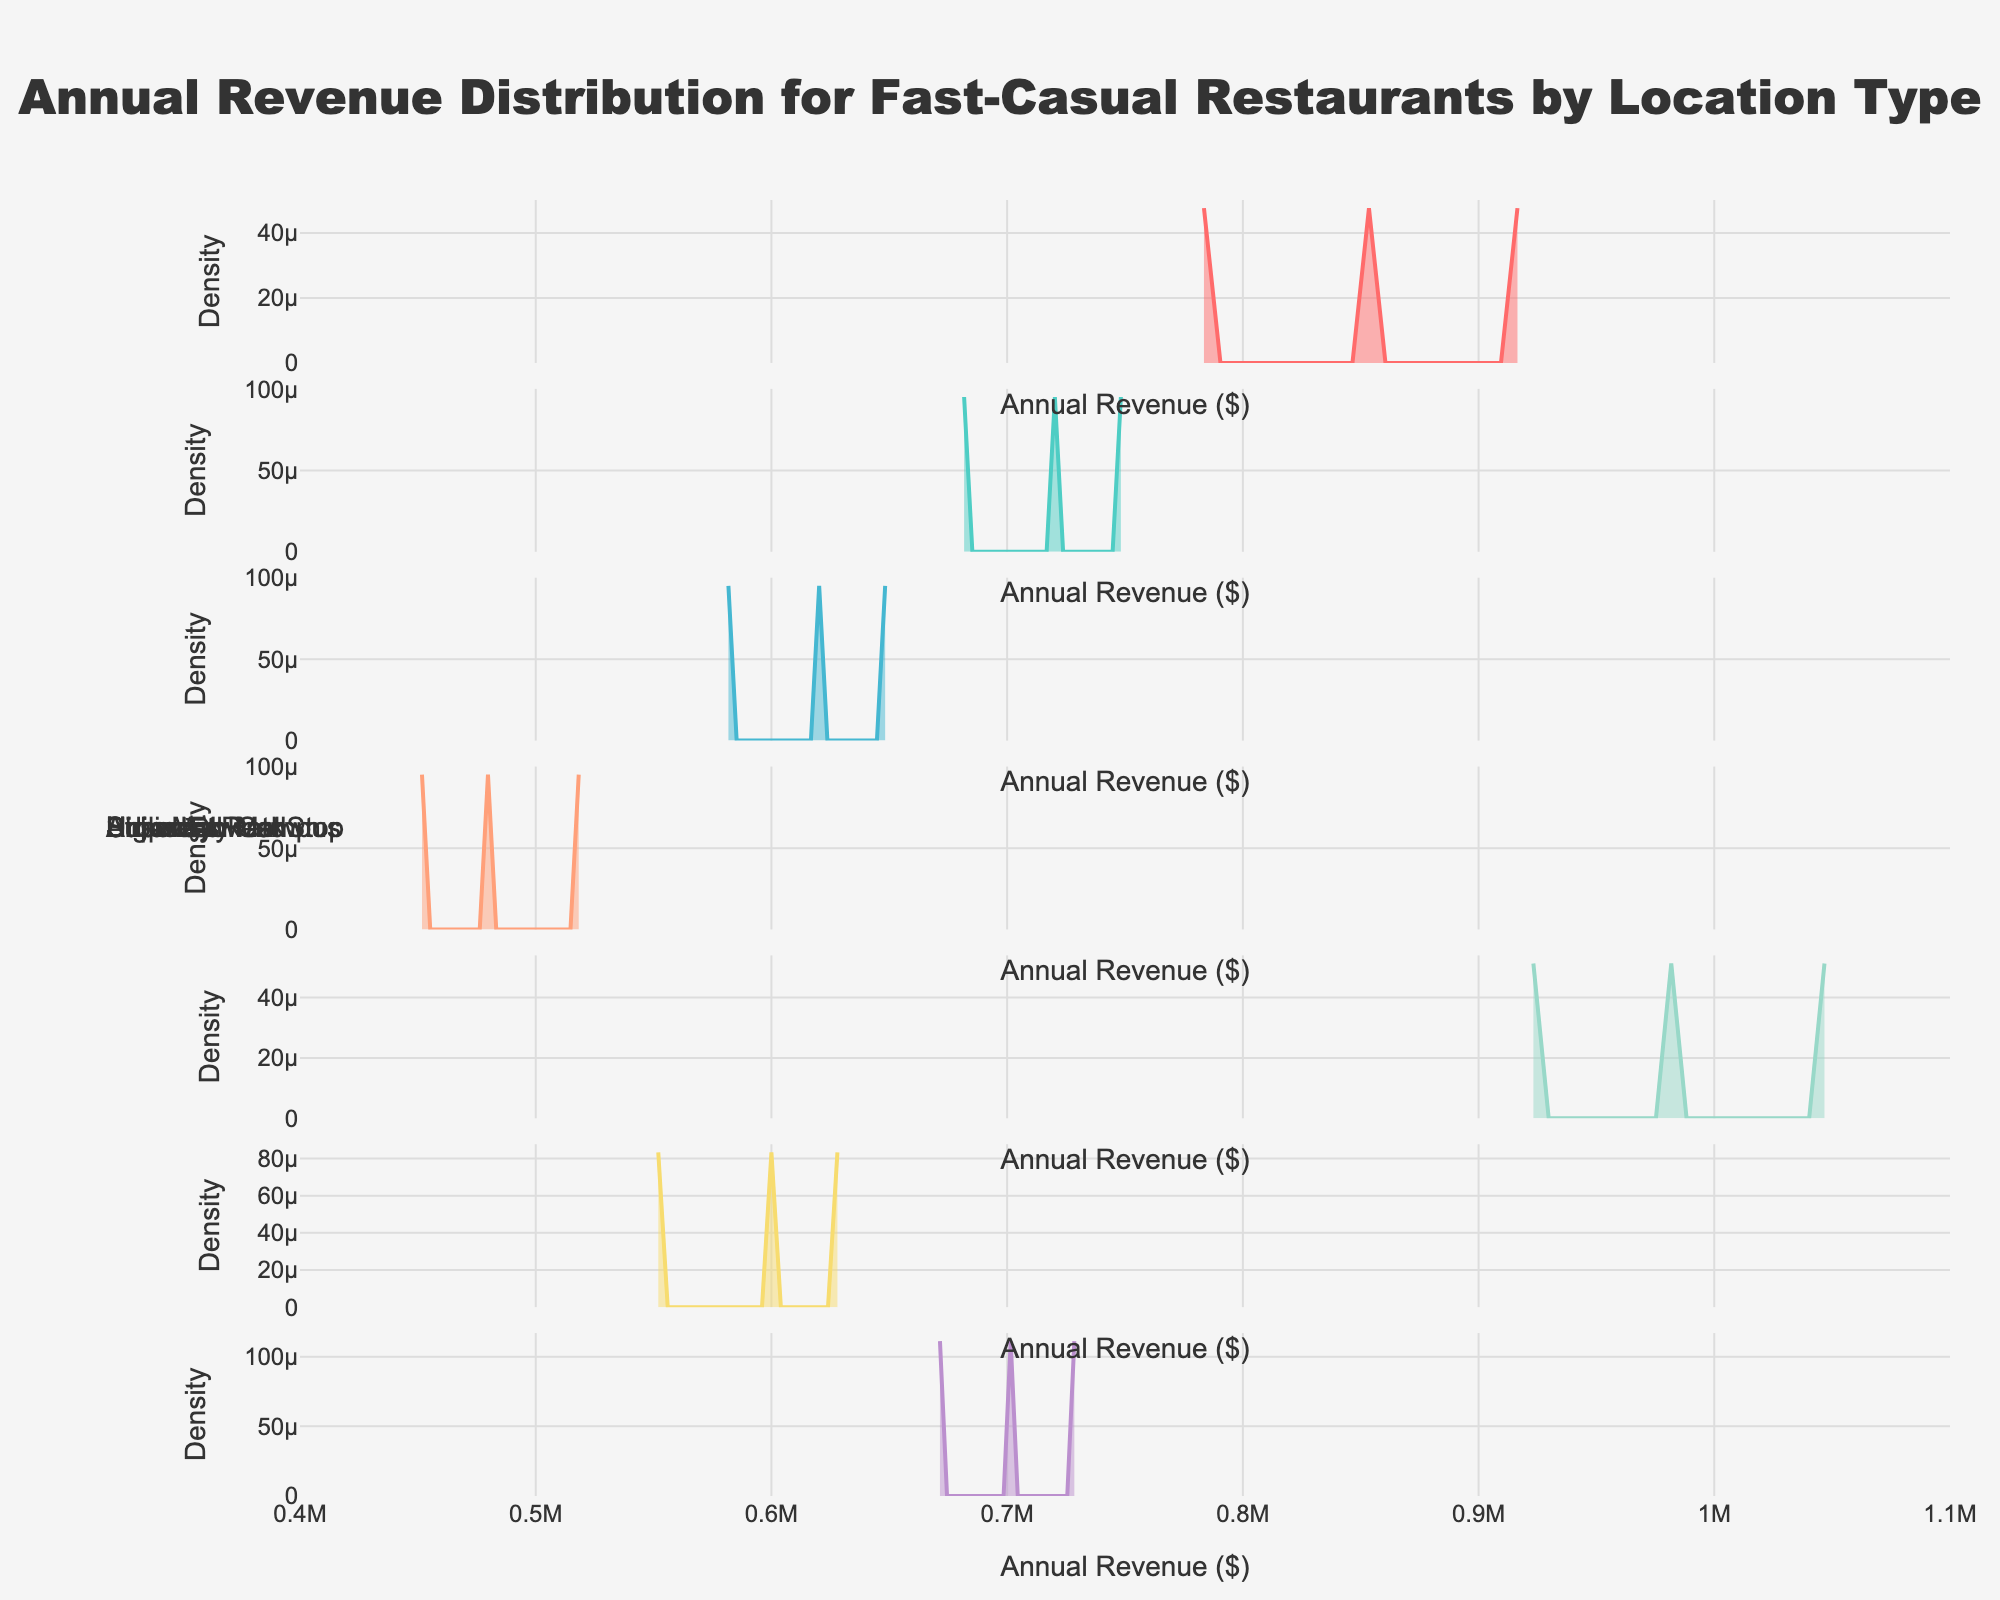What's the title of the figure? The title is usually prominently displayed at the top of the figure. The figure title in this case describes the data and the presentation method.
Answer: Annual Revenue Distribution for Fast-Casual Restaurants by Location Type What's shown on the x-axis? The x-axis usually represents the variable of interest in the plot. In this case, it represents the annual revenue in dollar amounts.
Answer: Annual Revenue ($) How many different location types are presented in the figure? The subplot titles indicate the number of different location types. Here, the figure includes subplots for Urban Downtown, Suburban Mall, Strip Mall, Highway Rest Stop, Airport, University Campus, and Business Park.
Answer: 7 Which location type shows the highest density peak for annual revenue? By examining the density curves, the highest peak represents the highest density. The Airport subplot shows the highest peak.
Answer: Airport What is the approximate annual revenue range for the Urban Downtown location type? The density curve for Urban Downtown extends across the x-axis. It appears to range from approximately $750,000 to $950,000.
Answer: $750,000 to $950,000 Compare Urban Downtown and Suburban Mall: which has a higher peak density? By looking at the density peaks, we observe that Urban Downtown has a higher peak density than Suburban Mall.
Answer: Urban Downtown What can you infer about the revenue distribution of Highway Rest Stop locations from the density plot? The density curve of Highway Rest Stop locations shows peaks at lower revenue values indicating that these locations generally have lower annual revenues compared with others. The curve is more spread out towards the lower end.
Answer: They generally have lower annual revenues How does the revenue distribution at University Campus locations compare to that at Business Park locations? By examining the density curves for both locations, we see that University Campus locations have lower revenue peaks compared to Business Parks, suggesting lower average revenues.
Answer: University Campus has lower average revenues What does the spread of the density curve indicate about the revenue consistency at Airport locations? A narrow and high peak for the Airport locations indicates a more consistent revenue range around the peak value.
Answer: High consistency around $980,000 to $1,050,000 Based on the plot, which location type would you consider most stable in terms of revenue and why? Stability in revenue could be inferred from a high, narrow density peak, indicating less variation. Airport locations have the narrowest and highest peaks, suggesting the least variation in annual revenue.
Answer: Airport due to narrow and high density peak 